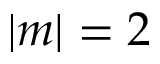Convert formula to latex. <formula><loc_0><loc_0><loc_500><loc_500>| m | = 2</formula> 